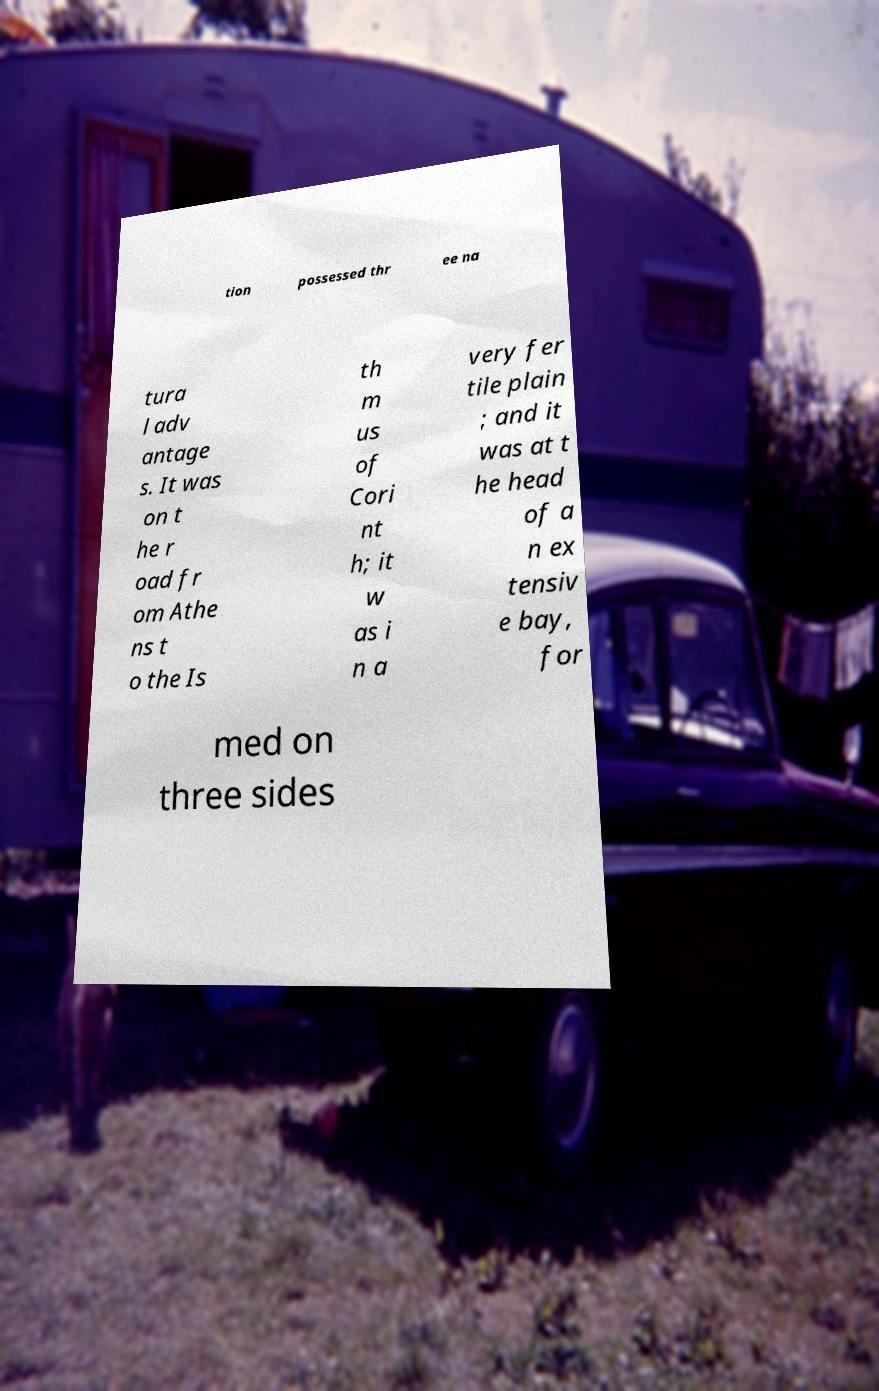Can you read and provide the text displayed in the image?This photo seems to have some interesting text. Can you extract and type it out for me? tion possessed thr ee na tura l adv antage s. It was on t he r oad fr om Athe ns t o the Is th m us of Cori nt h; it w as i n a very fer tile plain ; and it was at t he head of a n ex tensiv e bay, for med on three sides 